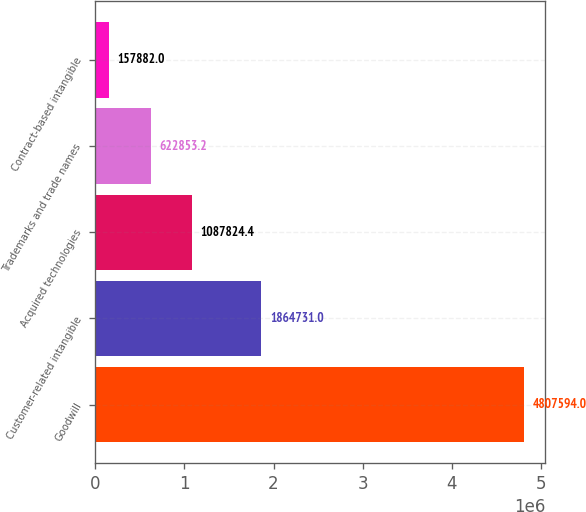Convert chart. <chart><loc_0><loc_0><loc_500><loc_500><bar_chart><fcel>Goodwill<fcel>Customer-related intangible<fcel>Acquired technologies<fcel>Trademarks and trade names<fcel>Contract-based intangible<nl><fcel>4.80759e+06<fcel>1.86473e+06<fcel>1.08782e+06<fcel>622853<fcel>157882<nl></chart> 